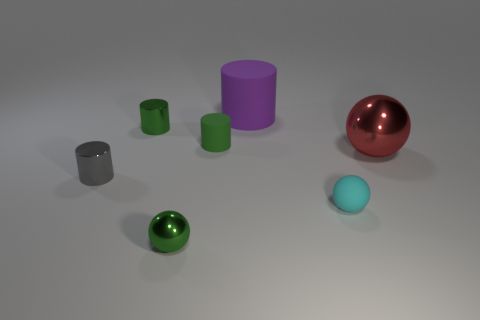Subtract all red spheres. How many spheres are left? 2 Subtract 4 cylinders. How many cylinders are left? 0 Subtract all balls. How many objects are left? 4 Add 1 green spheres. How many objects exist? 8 Subtract 0 yellow cylinders. How many objects are left? 7 Subtract all brown cylinders. Subtract all gray blocks. How many cylinders are left? 4 Subtract all green blocks. How many purple cylinders are left? 1 Subtract all big brown shiny objects. Subtract all tiny green matte cylinders. How many objects are left? 6 Add 7 small green metallic objects. How many small green metallic objects are left? 9 Add 6 purple matte objects. How many purple matte objects exist? 7 